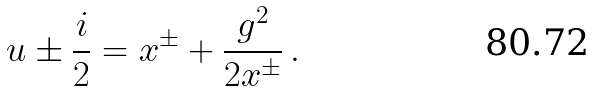<formula> <loc_0><loc_0><loc_500><loc_500>u \pm \frac { i } { 2 } = x ^ { \pm } + \frac { g ^ { 2 } } { 2 x ^ { \pm } } \, .</formula> 